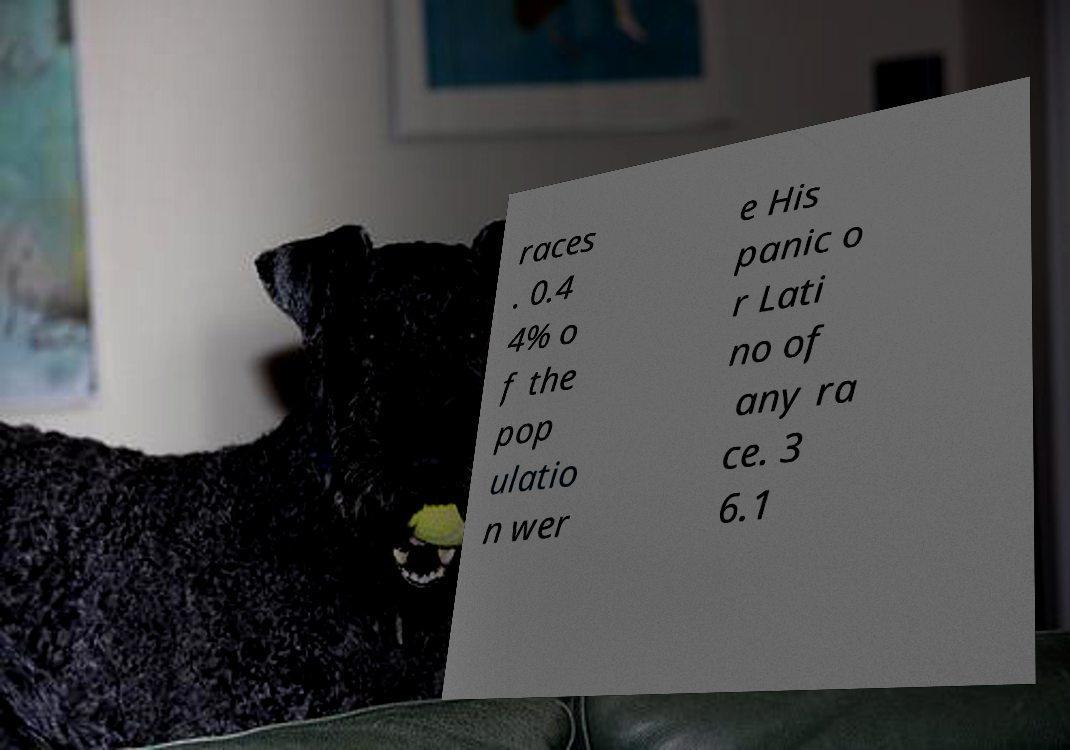Please identify and transcribe the text found in this image. races . 0.4 4% o f the pop ulatio n wer e His panic o r Lati no of any ra ce. 3 6.1 